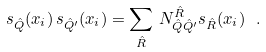<formula> <loc_0><loc_0><loc_500><loc_500>s _ { \hat { Q } } ( { x _ { i } } ) \, s _ { \hat { Q } ^ { \prime } } ( { x _ { i } } ) = \sum _ { \hat { R } } \, N _ { \hat { Q } \hat { Q } ^ { \prime } } ^ { \hat { R } } s _ { \hat { R } } ( { x _ { i } } ) \ .</formula> 